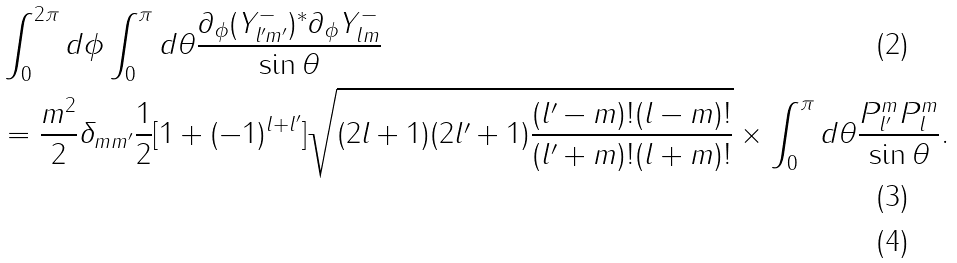Convert formula to latex. <formula><loc_0><loc_0><loc_500><loc_500>& \int _ { 0 } ^ { 2 \pi } d \phi \int _ { 0 } ^ { \pi } d \theta \frac { \partial _ { \phi } ( Y _ { l ^ { \prime } m ^ { \prime } } ^ { - } ) ^ { * } \partial _ { \phi } Y _ { l m } ^ { - } } { \sin \theta } \\ & = \frac { m ^ { 2 } } { 2 } \delta _ { m m ^ { \prime } } \frac { 1 } { 2 } [ 1 + ( - 1 ) ^ { l + l ^ { \prime } } ] \sqrt { ( 2 l + 1 ) ( 2 l ^ { \prime } + 1 ) \frac { ( l ^ { \prime } - m ) ! ( l - m ) ! } { ( l ^ { \prime } + m ) ! ( l + m ) ! } } \times \int _ { 0 } ^ { \pi } d \theta \frac { P _ { l ^ { \prime } } ^ { m } P _ { l } ^ { m } } { \sin \theta } . \\</formula> 